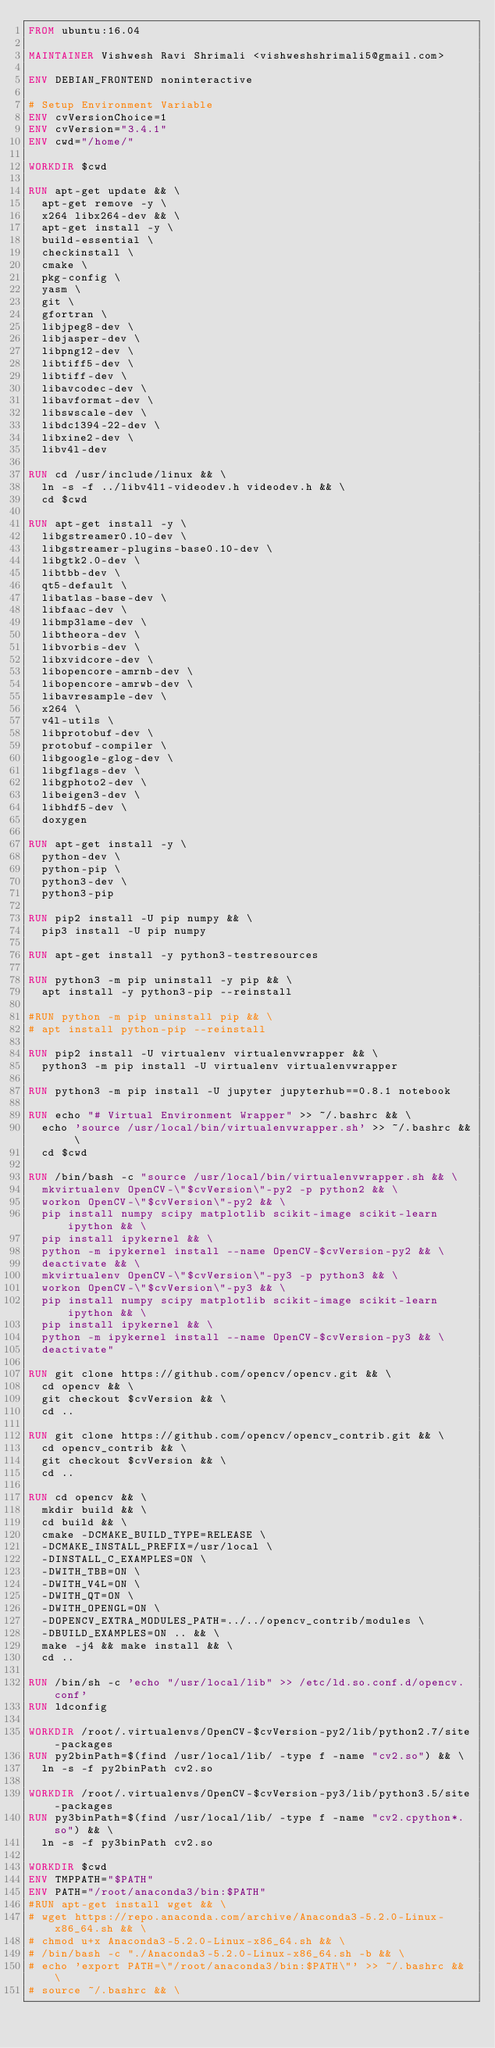Convert code to text. <code><loc_0><loc_0><loc_500><loc_500><_Dockerfile_>FROM ubuntu:16.04

MAINTAINER Vishwesh Ravi Shrimali <vishweshshrimali5@gmail.com>

ENV DEBIAN_FRONTEND noninteractive

# Setup Environment Variable
ENV cvVersionChoice=1
ENV cvVersion="3.4.1"
ENV cwd="/home/"

WORKDIR $cwd

RUN apt-get update && \
	apt-get remove -y \
	x264 libx264-dev && \
	apt-get install -y \
	build-essential \
	checkinstall \
	cmake \
	pkg-config \
	yasm \
	git \
	gfortran \
	libjpeg8-dev \
	libjasper-dev \
	libpng12-dev \
	libtiff5-dev \
	libtiff-dev \
	libavcodec-dev \
	libavformat-dev \
	libswscale-dev \
	libdc1394-22-dev \
	libxine2-dev \
	libv4l-dev

RUN cd /usr/include/linux && \
	ln -s -f ../libv4l1-videodev.h videodev.h && \
	cd $cwd

RUN apt-get install -y \
	libgstreamer0.10-dev \
	libgstreamer-plugins-base0.10-dev \
	libgtk2.0-dev \
	libtbb-dev \
	qt5-default \
	libatlas-base-dev \
	libfaac-dev \
	libmp3lame-dev \
	libtheora-dev \
	libvorbis-dev \
	libxvidcore-dev \
	libopencore-amrnb-dev \
	libopencore-amrwb-dev \
	libavresample-dev \
	x264 \
	v4l-utils \
	libprotobuf-dev \
	protobuf-compiler \
	libgoogle-glog-dev \
	libgflags-dev \
	libgphoto2-dev \
	libeigen3-dev \
	libhdf5-dev \
	doxygen

RUN apt-get install -y \
	python-dev \
	python-pip \
	python3-dev \
	python3-pip

RUN pip2 install -U pip numpy && \
	pip3 install -U pip numpy

RUN apt-get install -y python3-testresources

RUN python3 -m pip uninstall -y pip && \
	apt install -y python3-pip --reinstall

#RUN python -m pip uninstall pip && \
#	apt install python-pip --reinstall

RUN pip2 install -U virtualenv virtualenvwrapper && \
	python3 -m pip install -U virtualenv virtualenvwrapper

RUN python3 -m pip install -U jupyter jupyterhub==0.8.1 notebook

RUN echo "# Virtual Environment Wrapper" >> ~/.bashrc && \
	echo 'source /usr/local/bin/virtualenvwrapper.sh' >> ~/.bashrc && \
	cd $cwd

RUN /bin/bash -c "source /usr/local/bin/virtualenvwrapper.sh && \
	mkvirtualenv OpenCV-\"$cvVersion\"-py2 -p python2 && \
	workon OpenCV-\"$cvVersion\"-py2 && \
	pip install numpy scipy matplotlib scikit-image scikit-learn ipython && \
	pip install ipykernel && \
	python -m ipykernel install --name OpenCV-$cvVersion-py2 && \
	deactivate && \
	mkvirtualenv OpenCV-\"$cvVersion\"-py3 -p python3 && \
	workon OpenCV-\"$cvVersion\"-py3 && \
	pip install numpy scipy matplotlib scikit-image scikit-learn ipython && \
	pip install ipykernel && \
	python -m ipykernel install --name OpenCV-$cvVersion-py3 && \
	deactivate"

RUN git clone https://github.com/opencv/opencv.git && \
	cd opencv && \
	git checkout $cvVersion && \
	cd ..

RUN git clone https://github.com/opencv/opencv_contrib.git && \
	cd opencv_contrib && \
	git checkout $cvVersion && \
	cd ..

RUN cd opencv && \
	mkdir build && \
	cd build && \
	cmake -DCMAKE_BUILD_TYPE=RELEASE \
	-DCMAKE_INSTALL_PREFIX=/usr/local \
	-DINSTALL_C_EXAMPLES=ON \
	-DWITH_TBB=ON \
	-DWITH_V4L=ON \
	-DWITH_QT=ON \
	-DWITH_OPENGL=ON \
	-DOPENCV_EXTRA_MODULES_PATH=../../opencv_contrib/modules \
	-DBUILD_EXAMPLES=ON .. && \
	make -j4 && make install && \
	cd ..

RUN /bin/sh -c 'echo "/usr/local/lib" >> /etc/ld.so.conf.d/opencv.conf'
RUN ldconfig

WORKDIR /root/.virtualenvs/OpenCV-$cvVersion-py2/lib/python2.7/site-packages
RUN py2binPath=$(find /usr/local/lib/ -type f -name "cv2.so") && \
	ln -s -f py2binPath cv2.so

WORKDIR /root/.virtualenvs/OpenCV-$cvVersion-py3/lib/python3.5/site-packages
RUN py3binPath=$(find /usr/local/lib/ -type f -name "cv2.cpython*.so") && \
	ln -s -f py3binPath cv2.so

WORKDIR $cwd
ENV TMPPATH="$PATH"
ENV PATH="/root/anaconda3/bin:$PATH"
#RUN apt-get install wget && \
#	wget https://repo.anaconda.com/archive/Anaconda3-5.2.0-Linux-x86_64.sh && \
#	chmod u+x Anaconda3-5.2.0-Linux-x86_64.sh && \
#	/bin/bash -c "./Anaconda3-5.2.0-Linux-x86_64.sh -b && \
#	echo 'export PATH=\"/root/anaconda3/bin:$PATH\"' >> ~/.bashrc && \
#	source ~/.bashrc && \</code> 